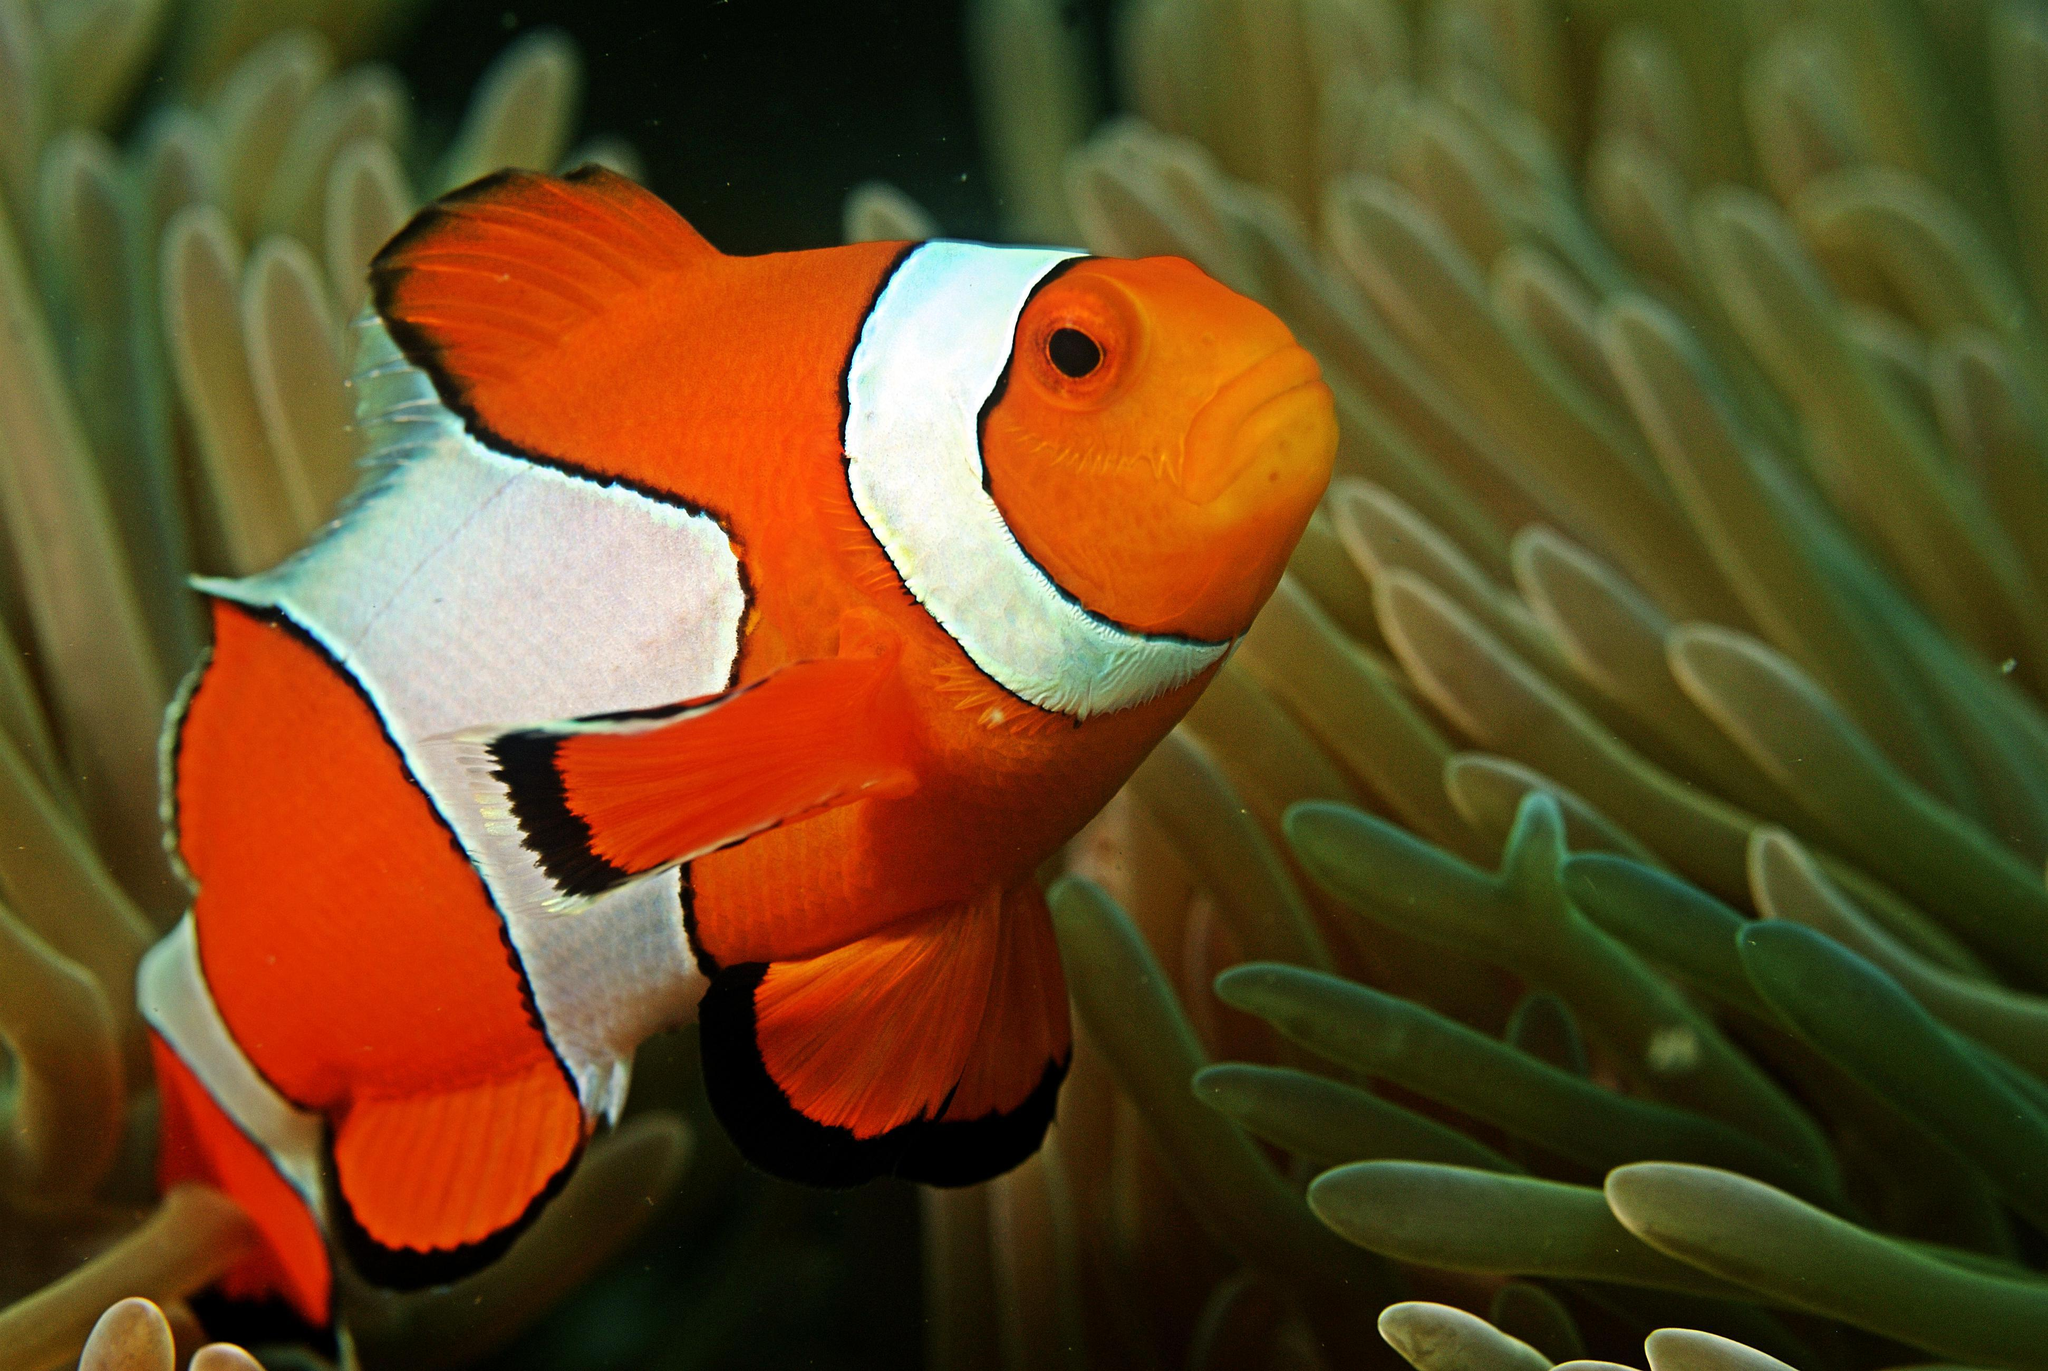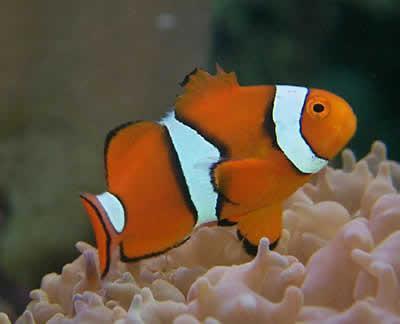The first image is the image on the left, the second image is the image on the right. Assess this claim about the two images: "The images show a total of two orange-faced fish swimming rightward.". Correct or not? Answer yes or no. Yes. 